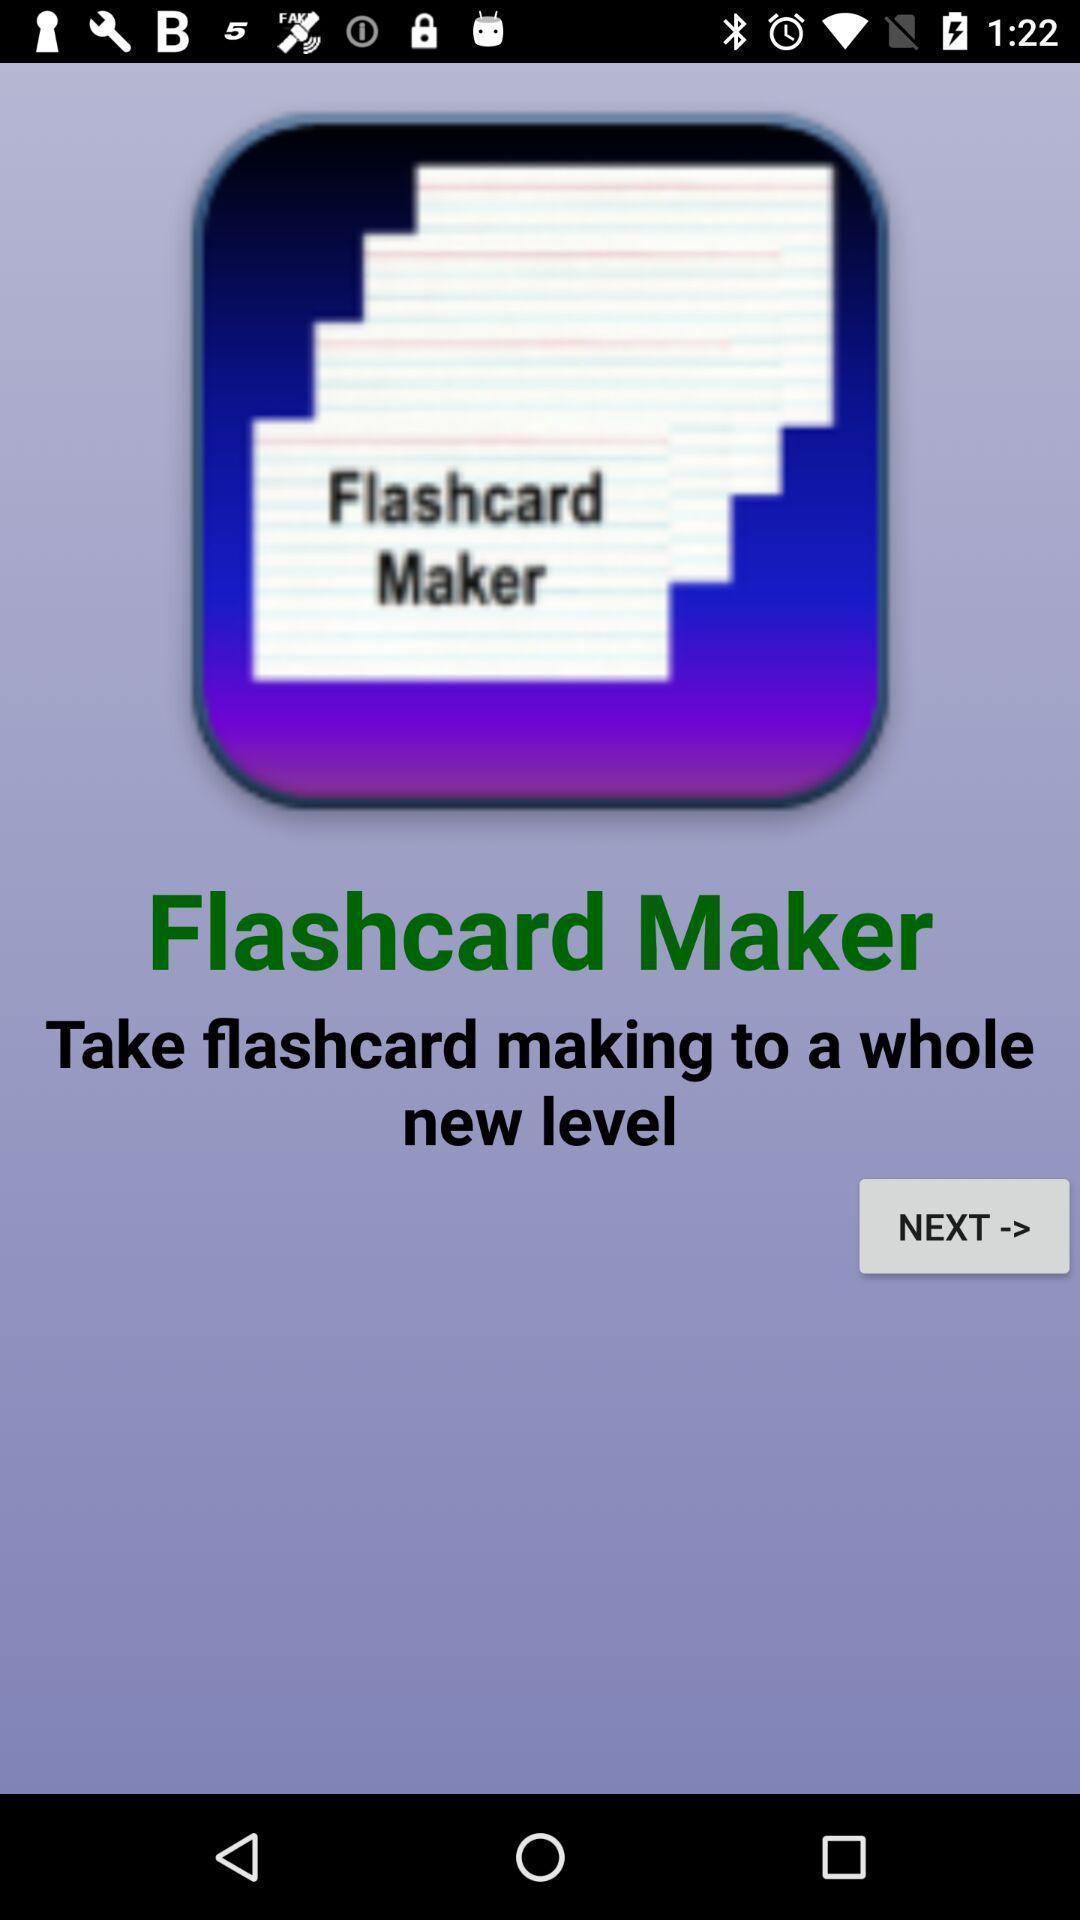Give me a summary of this screen capture. Screen shows about a flashcard maker. 